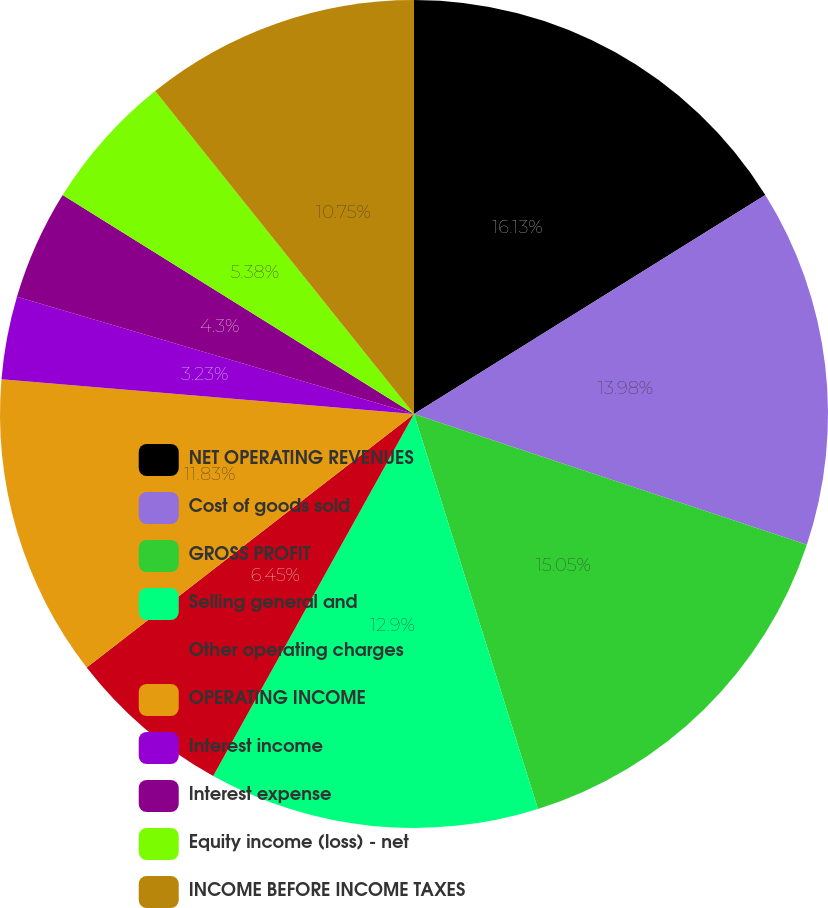Convert chart to OTSL. <chart><loc_0><loc_0><loc_500><loc_500><pie_chart><fcel>NET OPERATING REVENUES<fcel>Cost of goods sold<fcel>GROSS PROFIT<fcel>Selling general and<fcel>Other operating charges<fcel>OPERATING INCOME<fcel>Interest income<fcel>Interest expense<fcel>Equity income (loss) - net<fcel>INCOME BEFORE INCOME TAXES<nl><fcel>16.13%<fcel>13.98%<fcel>15.05%<fcel>12.9%<fcel>6.45%<fcel>11.83%<fcel>3.23%<fcel>4.3%<fcel>5.38%<fcel>10.75%<nl></chart> 